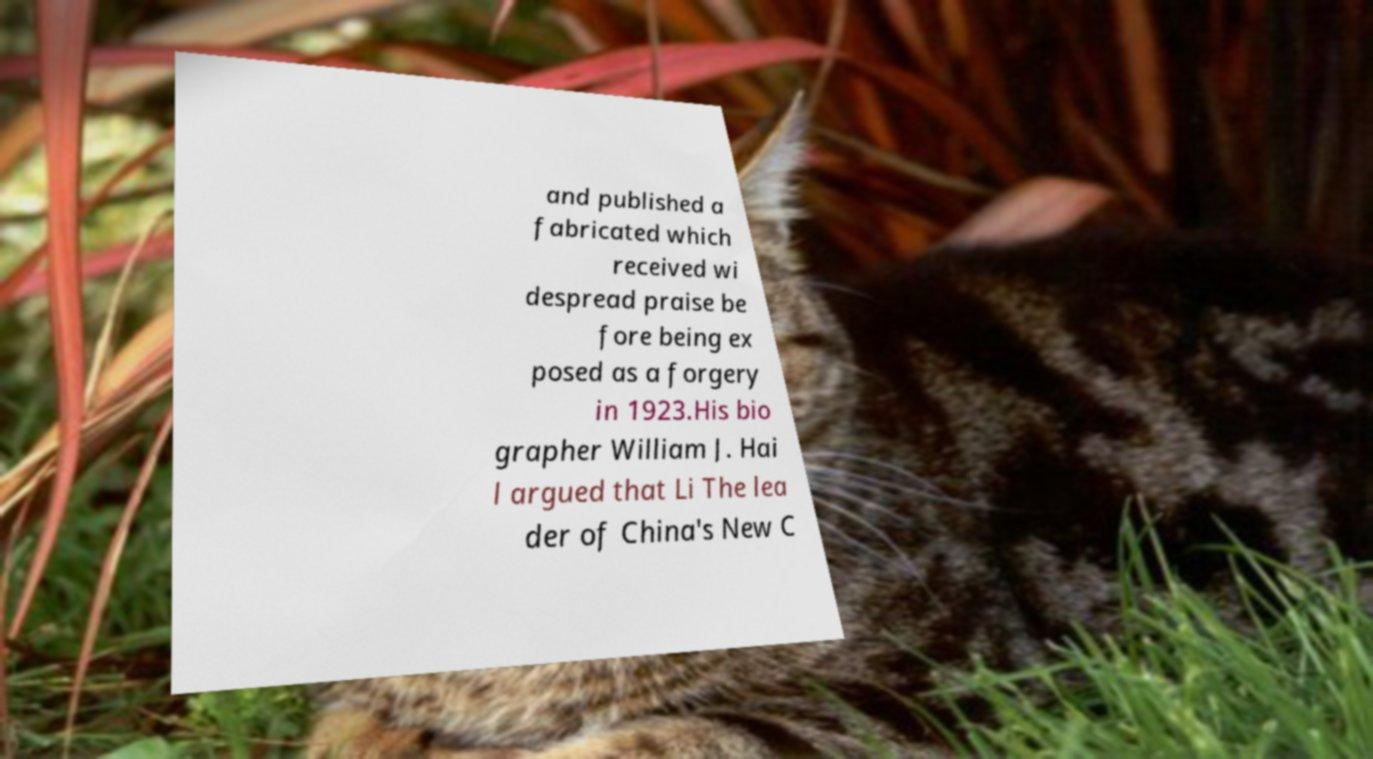Please identify and transcribe the text found in this image. and published a fabricated which received wi despread praise be fore being ex posed as a forgery in 1923.His bio grapher William J. Hai l argued that Li The lea der of China's New C 